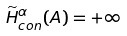Convert formula to latex. <formula><loc_0><loc_0><loc_500><loc_500>\widetilde { H } ^ { \alpha } _ { c o n } ( A ) = + \infty</formula> 